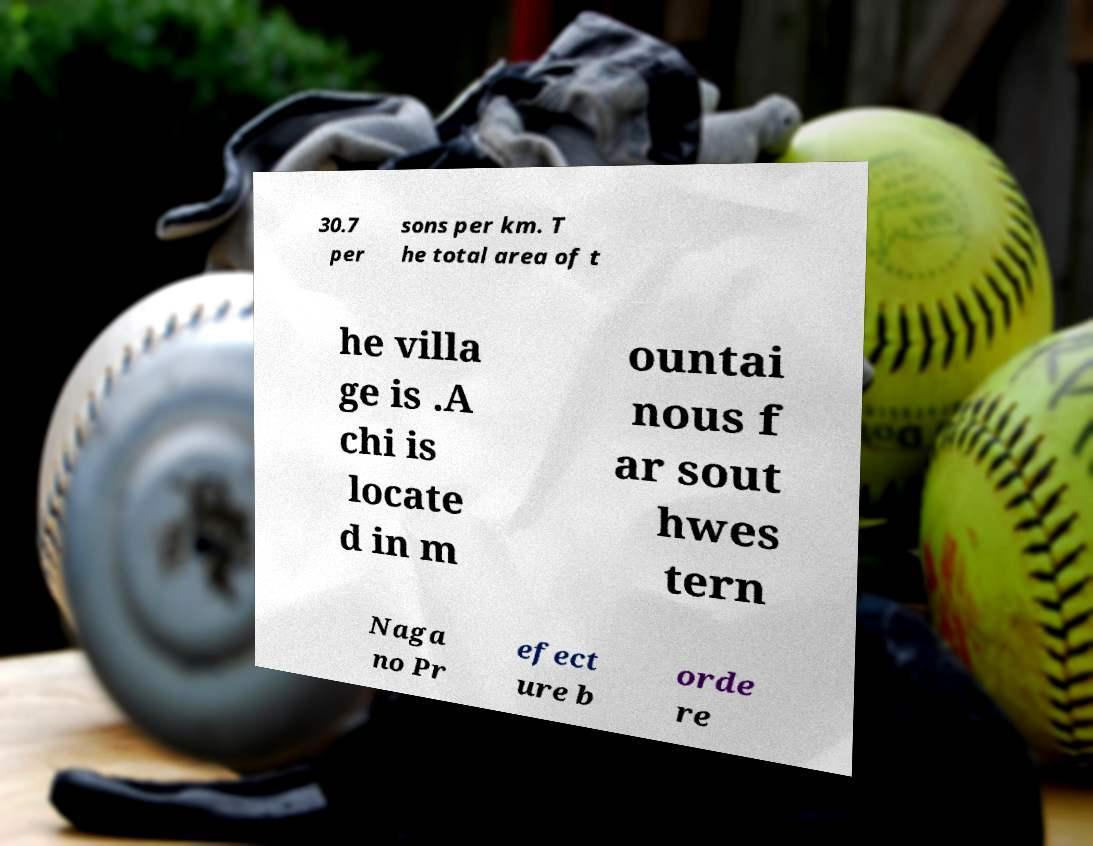Please identify and transcribe the text found in this image. 30.7 per sons per km. T he total area of t he villa ge is .A chi is locate d in m ountai nous f ar sout hwes tern Naga no Pr efect ure b orde re 